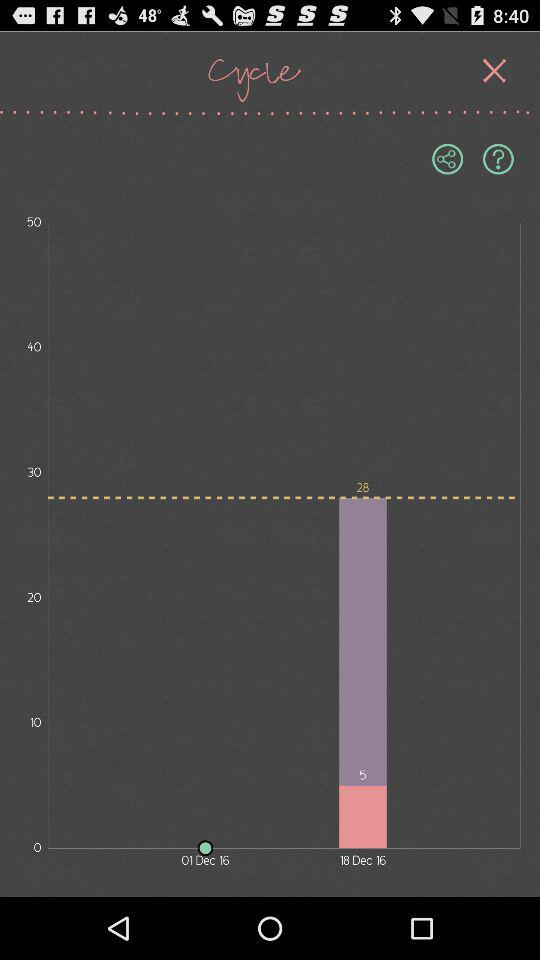What is the date of the next cycle? The date is January 15. 